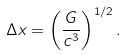Convert formula to latex. <formula><loc_0><loc_0><loc_500><loc_500>\Delta x = \left ( \frac { G } { c ^ { 3 } } \right ) ^ { 1 / 2 } .</formula> 